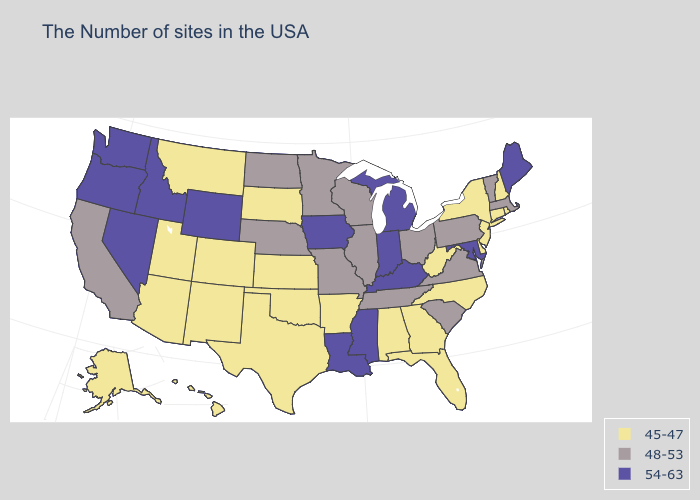Name the states that have a value in the range 45-47?
Write a very short answer. Rhode Island, New Hampshire, Connecticut, New York, New Jersey, Delaware, North Carolina, West Virginia, Florida, Georgia, Alabama, Arkansas, Kansas, Oklahoma, Texas, South Dakota, Colorado, New Mexico, Utah, Montana, Arizona, Alaska, Hawaii. What is the value of Mississippi?
Be succinct. 54-63. What is the highest value in states that border Nevada?
Keep it brief. 54-63. Does Oregon have the same value as Rhode Island?
Short answer required. No. What is the highest value in states that border Nebraska?
Short answer required. 54-63. Does North Dakota have the highest value in the USA?
Quick response, please. No. Is the legend a continuous bar?
Quick response, please. No. Does Washington have the same value as Tennessee?
Be succinct. No. Name the states that have a value in the range 45-47?
Answer briefly. Rhode Island, New Hampshire, Connecticut, New York, New Jersey, Delaware, North Carolina, West Virginia, Florida, Georgia, Alabama, Arkansas, Kansas, Oklahoma, Texas, South Dakota, Colorado, New Mexico, Utah, Montana, Arizona, Alaska, Hawaii. What is the value of Maryland?
Write a very short answer. 54-63. What is the value of Minnesota?
Give a very brief answer. 48-53. Name the states that have a value in the range 48-53?
Quick response, please. Massachusetts, Vermont, Pennsylvania, Virginia, South Carolina, Ohio, Tennessee, Wisconsin, Illinois, Missouri, Minnesota, Nebraska, North Dakota, California. What is the highest value in the South ?
Be succinct. 54-63. Which states have the lowest value in the South?
Quick response, please. Delaware, North Carolina, West Virginia, Florida, Georgia, Alabama, Arkansas, Oklahoma, Texas. Does Colorado have the highest value in the USA?
Be succinct. No. 